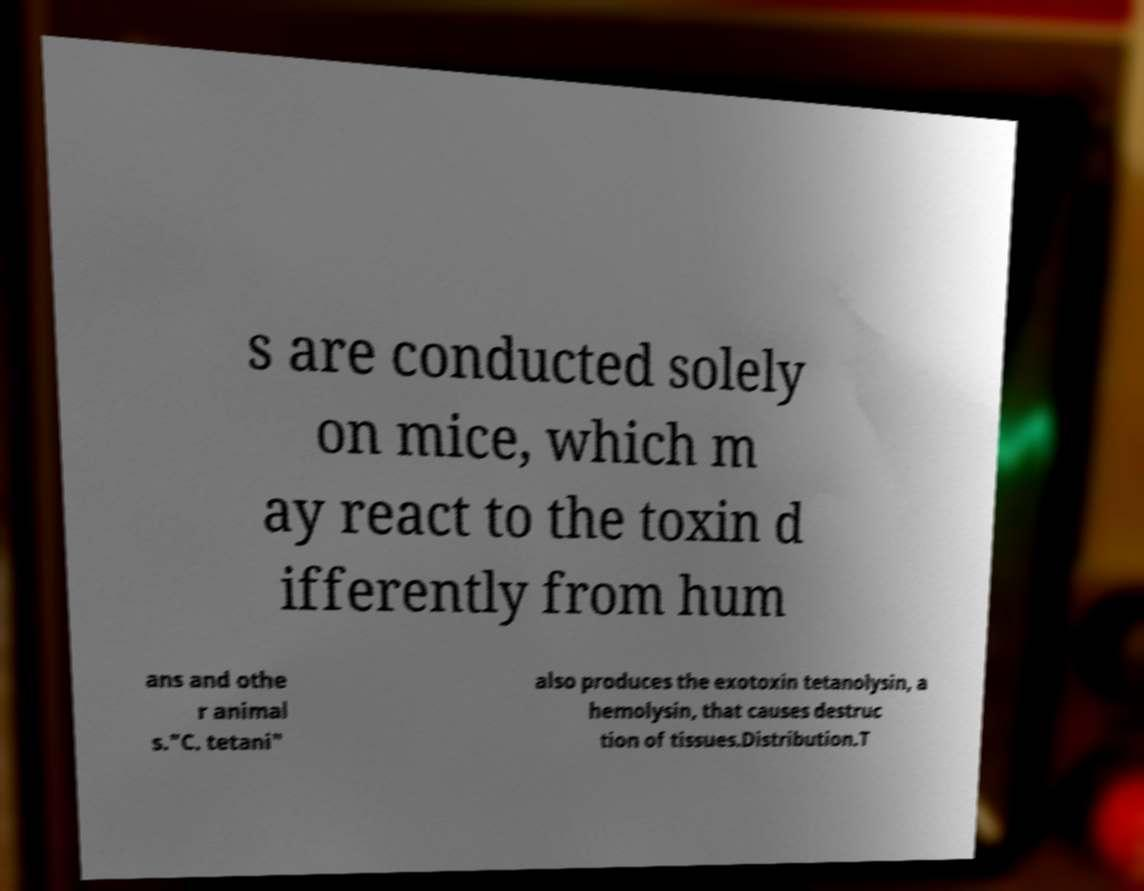Could you assist in decoding the text presented in this image and type it out clearly? s are conducted solely on mice, which m ay react to the toxin d ifferently from hum ans and othe r animal s."C. tetani" also produces the exotoxin tetanolysin, a hemolysin, that causes destruc tion of tissues.Distribution.T 